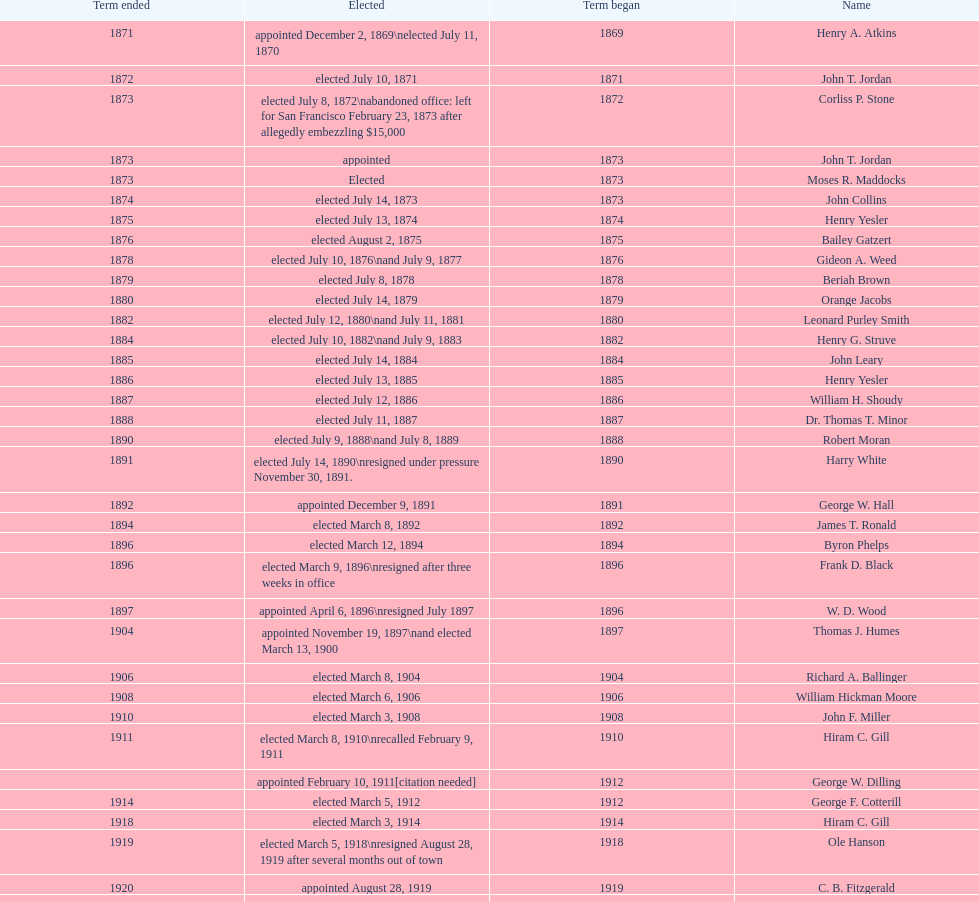Would you be able to parse every entry in this table? {'header': ['Term ended', 'Elected', 'Term began', 'Name'], 'rows': [['1871', 'appointed December 2, 1869\\nelected July 11, 1870', '1869', 'Henry A. Atkins'], ['1872', 'elected July 10, 1871', '1871', 'John T. Jordan'], ['1873', 'elected July 8, 1872\\nabandoned office: left for San Francisco February 23, 1873 after allegedly embezzling $15,000', '1872', 'Corliss P. Stone'], ['1873', 'appointed', '1873', 'John T. Jordan'], ['1873', 'Elected', '1873', 'Moses R. Maddocks'], ['1874', 'elected July 14, 1873', '1873', 'John Collins'], ['1875', 'elected July 13, 1874', '1874', 'Henry Yesler'], ['1876', 'elected August 2, 1875', '1875', 'Bailey Gatzert'], ['1878', 'elected July 10, 1876\\nand July 9, 1877', '1876', 'Gideon A. Weed'], ['1879', 'elected July 8, 1878', '1878', 'Beriah Brown'], ['1880', 'elected July 14, 1879', '1879', 'Orange Jacobs'], ['1882', 'elected July 12, 1880\\nand July 11, 1881', '1880', 'Leonard Purley Smith'], ['1884', 'elected July 10, 1882\\nand July 9, 1883', '1882', 'Henry G. Struve'], ['1885', 'elected July 14, 1884', '1884', 'John Leary'], ['1886', 'elected July 13, 1885', '1885', 'Henry Yesler'], ['1887', 'elected July 12, 1886', '1886', 'William H. Shoudy'], ['1888', 'elected July 11, 1887', '1887', 'Dr. Thomas T. Minor'], ['1890', 'elected July 9, 1888\\nand July 8, 1889', '1888', 'Robert Moran'], ['1891', 'elected July 14, 1890\\nresigned under pressure November 30, 1891.', '1890', 'Harry White'], ['1892', 'appointed December 9, 1891', '1891', 'George W. Hall'], ['1894', 'elected March 8, 1892', '1892', 'James T. Ronald'], ['1896', 'elected March 12, 1894', '1894', 'Byron Phelps'], ['1896', 'elected March 9, 1896\\nresigned after three weeks in office', '1896', 'Frank D. Black'], ['1897', 'appointed April 6, 1896\\nresigned July 1897', '1896', 'W. D. Wood'], ['1904', 'appointed November 19, 1897\\nand elected March 13, 1900', '1897', 'Thomas J. Humes'], ['1906', 'elected March 8, 1904', '1904', 'Richard A. Ballinger'], ['1908', 'elected March 6, 1906', '1906', 'William Hickman Moore'], ['1910', 'elected March 3, 1908', '1908', 'John F. Miller'], ['1911', 'elected March 8, 1910\\nrecalled February 9, 1911', '1910', 'Hiram C. Gill'], ['', 'appointed February 10, 1911[citation needed]', '1912', 'George W. Dilling'], ['1914', 'elected March 5, 1912', '1912', 'George F. Cotterill'], ['1918', 'elected March 3, 1914', '1914', 'Hiram C. Gill'], ['1919', 'elected March 5, 1918\\nresigned August 28, 1919 after several months out of town', '1918', 'Ole Hanson'], ['1920', 'appointed August 28, 1919', '1919', 'C. B. Fitzgerald'], ['1922', 'elected March 2, 1920', '1920', 'Hugh M. Caldwell'], ['1926', 'elected May 2, 1922\\nand March 4, 1924', '1922', 'Edwin J. Brown'], ['1928', 'elected March 9, 1926', '1926', 'Bertha Knight Landes'], ['1931', 'elected March 6, 1928\\nand March 4, 1930\\nrecalled July 13, 1931', '1928', 'Frank E. Edwards'], ['1932', 'appointed July 14, 1931', '1931', 'Robert H. Harlin'], ['1934', 'elected March 8, 1932', '1932', 'John F. Dore'], ['1936', 'elected March 6, 1934', '1934', 'Charles L. Smith'], ['1938', 'elected March 3, 1936\\nbecame gravely ill and was relieved of office April 13, 1938, already a lame duck after the 1938 election. He died five days later.', '1936', 'John F. Dore'], ['1941', "elected March 8, 1938\\nappointed to take office early, April 27, 1938, after Dore's death.\\nelected March 5, 1940\\nresigned January 11, 1941, to become Governor of Washington", '1938', 'Arthur B. Langlie'], ['1941', 'appointed January 27, 1941', '1941', 'John E. Carroll'], ['1942', 'elected March 4, 1941', '1941', 'Earl Millikin'], ['1952', 'elected March 3, 1942, March 7, 1944, March 5, 1946, and March 2, 1948', '1942', 'William F. Devin'], ['1956', 'elected March 4, 1952', '1952', 'Allan Pomeroy'], ['1964', 'elected March 6, 1956\\nand March 8, 1960', '1956', 'Gordon S. Clinton'], ['1969', 'elected March 10, 1964\\nresigned March 23, 1969, to accept an appointment as an Assistant Secretary in the Department of Transportation in the Nixon administration.', '1964', "James d'Orma Braman"], ['1969', 'appointed March 23, 1969', '1969', 'Floyd C. Miller'], ['January 1, 1978', 'elected November 4, 1969\\nand November 6, 1973\\nsurvived recall attempt on July 1, 1975', 'December 1, 1969', 'Wesley C. Uhlman'], ['January 1, 1990', 'elected November 8, 1977, November 3, 1981, and November 5, 1985', 'January 1, 1978', 'Charles Royer'], ['January 1, 1998', 'elected November 7, 1989', 'January 1, 1990', 'Norman B. Rice'], ['January 1, 2002', 'elected November 4, 1997', 'January 1, 1998', 'Paul Schell'], ['January 1, 2010', 'elected November 6, 2001\\nand November 8, 2005', 'January 1, 2002', 'Gregory J. Nickels'], ['January 1, 2014', 'elected November 3, 2009', 'January 1, 2010', 'Michael McGinn'], ['present', 'elected November 5, 2013', 'January 1, 2014', 'Ed Murray']]} Who began their term in 1890? Harry White. 